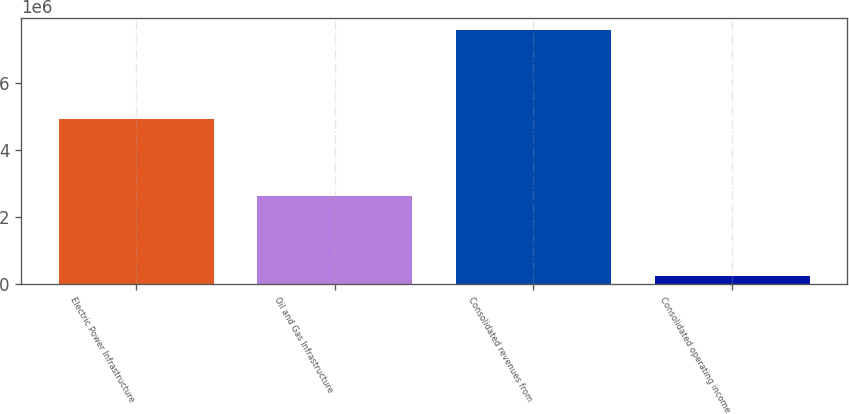Convert chart. <chart><loc_0><loc_0><loc_500><loc_500><bar_chart><fcel>Electric Power Infrastructure<fcel>Oil and Gas Infrastructure<fcel>Consolidated revenues from<fcel>Consolidated operating income<nl><fcel>4.93729e+06<fcel>2.63515e+06<fcel>7.57244e+06<fcel>237503<nl></chart> 